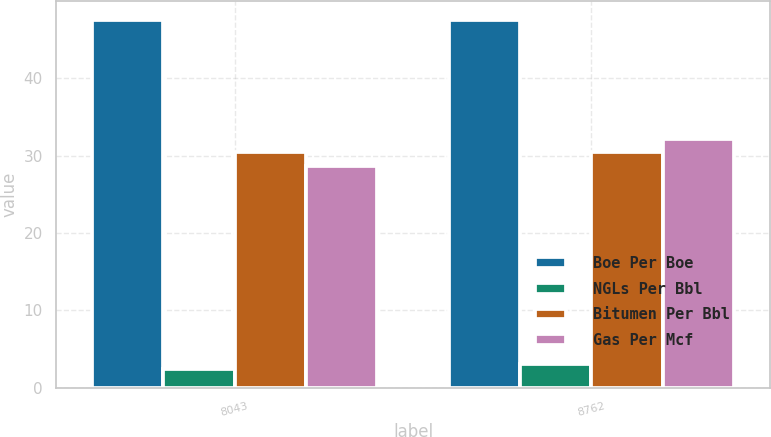<chart> <loc_0><loc_0><loc_500><loc_500><stacked_bar_chart><ecel><fcel>8043<fcel>8762<nl><fcel>Boe Per Boe<fcel>47.57<fcel>47.57<nl><fcel>NGLs Per Bbl<fcel>2.36<fcel>3.01<nl><fcel>Bitumen Per Bbl<fcel>30.42<fcel>30.46<nl><fcel>Gas Per Mcf<fcel>28.65<fcel>32.13<nl></chart> 